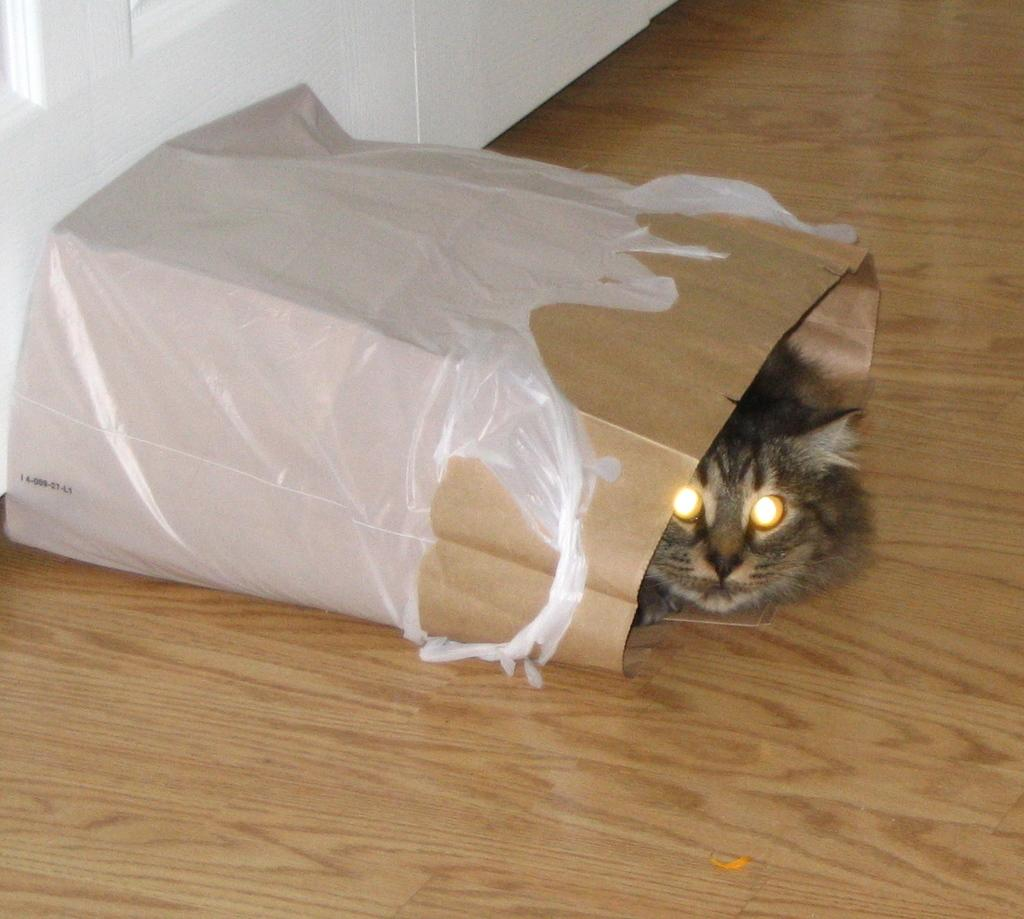What type of animal is in the image? There is a black cat in the image. How is the cat positioned in the image? The cat is inside a plastic bag. What color is the wall visible in the image? There is a white wall visible in the image. Where was the image taken? The image was taken inside a room. Can you see the boy holding the kettle in the image? There is no boy or kettle present in the image; it only features a black cat inside a plastic bag and a white wall. 